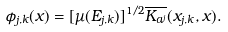<formula> <loc_0><loc_0><loc_500><loc_500>\phi _ { j , k } ( x ) = [ \mu ( E _ { j , k } ) ] ^ { 1 / 2 } \overline { K _ { a ^ { j } } } ( x _ { j , k } , x ) .</formula> 